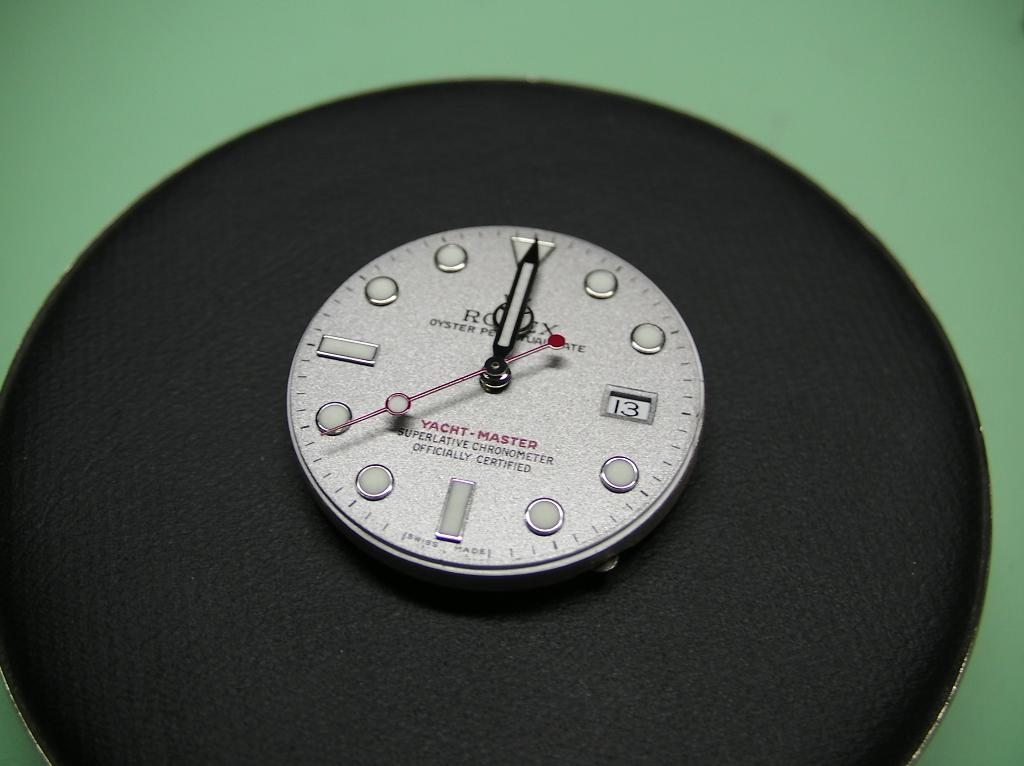<image>
Summarize the visual content of the image. A watch shows 13 seconds on the face. 